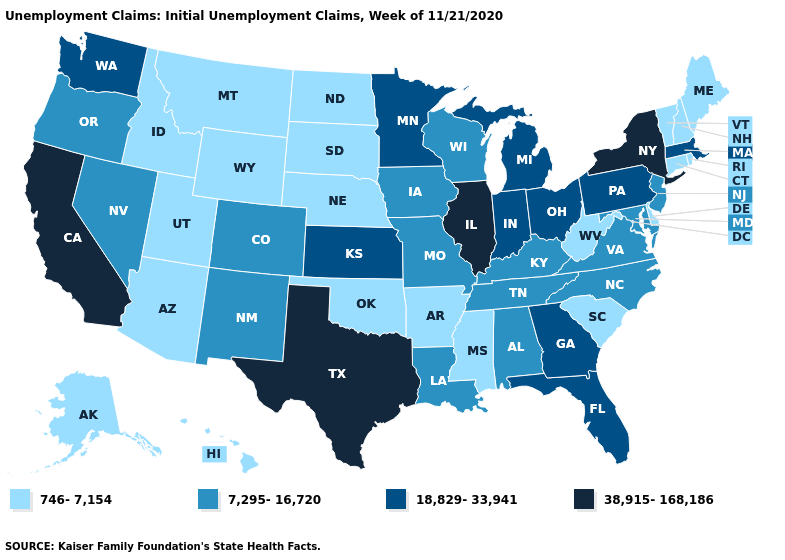What is the lowest value in the USA?
Quick response, please. 746-7,154. What is the lowest value in states that border Idaho?
Keep it brief. 746-7,154. What is the value of South Dakota?
Short answer required. 746-7,154. Name the states that have a value in the range 746-7,154?
Quick response, please. Alaska, Arizona, Arkansas, Connecticut, Delaware, Hawaii, Idaho, Maine, Mississippi, Montana, Nebraska, New Hampshire, North Dakota, Oklahoma, Rhode Island, South Carolina, South Dakota, Utah, Vermont, West Virginia, Wyoming. What is the value of New Hampshire?
Concise answer only. 746-7,154. What is the lowest value in states that border Minnesota?
Write a very short answer. 746-7,154. Which states have the highest value in the USA?
Keep it brief. California, Illinois, New York, Texas. Does Ohio have a higher value than New York?
Be succinct. No. Which states hav the highest value in the MidWest?
Short answer required. Illinois. Does New York have the lowest value in the Northeast?
Keep it brief. No. Among the states that border Colorado , does Kansas have the highest value?
Give a very brief answer. Yes. What is the lowest value in the MidWest?
Give a very brief answer. 746-7,154. Which states hav the highest value in the South?
Keep it brief. Texas. What is the value of Wyoming?
Concise answer only. 746-7,154. What is the value of Washington?
Give a very brief answer. 18,829-33,941. 